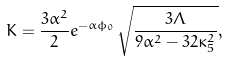<formula> <loc_0><loc_0><loc_500><loc_500>K = \frac { 3 \alpha ^ { 2 } } { 2 } e ^ { - \alpha \phi _ { 0 } } \sqrt { \frac { 3 \Lambda } { 9 \alpha ^ { 2 } - 3 2 \kappa _ { 5 } ^ { 2 } } } ,</formula> 